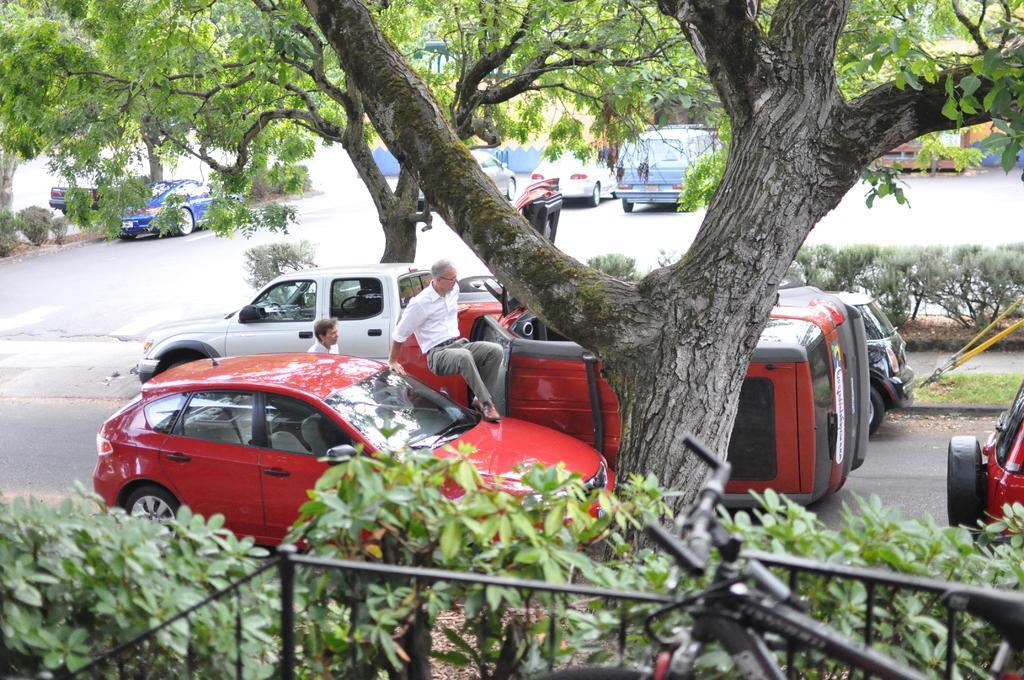Could you give a brief overview of what you see in this image? In the foreground of the picture there are plants, railing and a tree. In the center of the picture there are vehicles, people, grass, plants on the road. In the background there are cars, trees, buildings and road. 